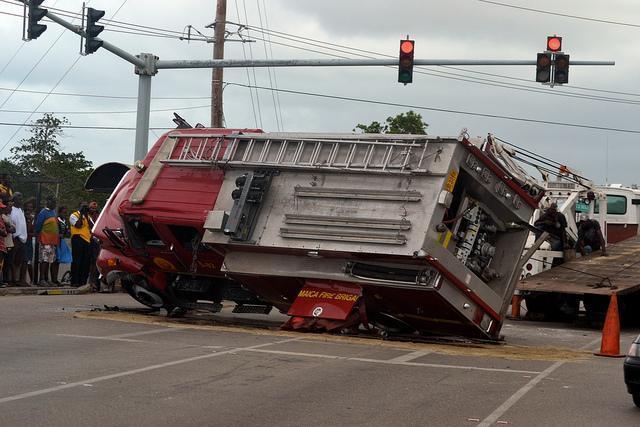How many traffic lights do you see?
Give a very brief answer. 4. How many horses are in the picture?
Give a very brief answer. 0. 